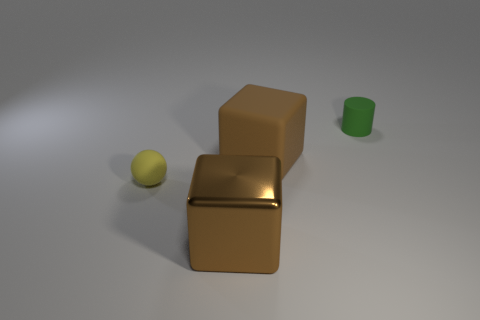Add 3 brown cubes. How many objects exist? 7 Subtract 0 green balls. How many objects are left? 4 Subtract all cylinders. How many objects are left? 3 Subtract 1 cylinders. How many cylinders are left? 0 Subtract all blue cubes. Subtract all brown balls. How many cubes are left? 2 Subtract all yellow cylinders. How many gray spheres are left? 0 Subtract all small green things. Subtract all small matte spheres. How many objects are left? 2 Add 2 small yellow things. How many small yellow things are left? 3 Add 2 red matte things. How many red matte things exist? 2 